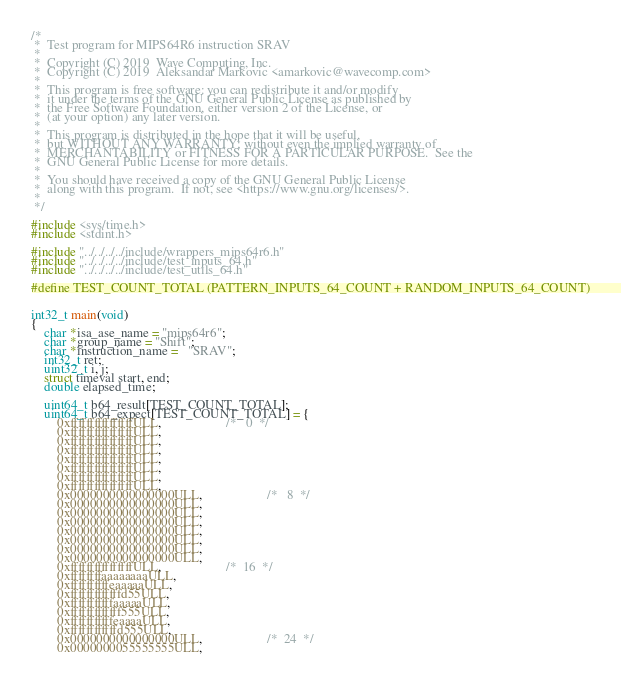Convert code to text. <code><loc_0><loc_0><loc_500><loc_500><_C_>/*
 *  Test program for MIPS64R6 instruction SRAV
 *
 *  Copyright (C) 2019  Wave Computing, Inc.
 *  Copyright (C) 2019  Aleksandar Markovic <amarkovic@wavecomp.com>
 *
 *  This program is free software: you can redistribute it and/or modify
 *  it under the terms of the GNU General Public License as published by
 *  the Free Software Foundation, either version 2 of the License, or
 *  (at your option) any later version.
 *
 *  This program is distributed in the hope that it will be useful,
 *  but WITHOUT ANY WARRANTY; without even the implied warranty of
 *  MERCHANTABILITY or FITNESS FOR A PARTICULAR PURPOSE.  See the
 *  GNU General Public License for more details.
 *
 *  You should have received a copy of the GNU General Public License
 *  along with this program.  If not, see <https://www.gnu.org/licenses/>.
 *
 */

#include <sys/time.h>
#include <stdint.h>

#include "../../../../include/wrappers_mips64r6.h"
#include "../../../../include/test_inputs_64.h"
#include "../../../../include/test_utils_64.h"

#define TEST_COUNT_TOTAL (PATTERN_INPUTS_64_COUNT + RANDOM_INPUTS_64_COUNT)


int32_t main(void)
{
    char *isa_ase_name = "mips64r6";
    char *group_name = "Shift";
    char *instruction_name =   "SRAV";
    int32_t ret;
    uint32_t i, j;
    struct timeval start, end;
    double elapsed_time;

    uint64_t b64_result[TEST_COUNT_TOTAL];
    uint64_t b64_expect[TEST_COUNT_TOTAL] = {
        0xffffffffffffffffULL,                    /*   0  */
        0xffffffffffffffffULL,
        0xffffffffffffffffULL,
        0xffffffffffffffffULL,
        0xffffffffffffffffULL,
        0xffffffffffffffffULL,
        0xffffffffffffffffULL,
        0xffffffffffffffffULL,
        0x0000000000000000ULL,                    /*   8  */
        0x0000000000000000ULL,
        0x0000000000000000ULL,
        0x0000000000000000ULL,
        0x0000000000000000ULL,
        0x0000000000000000ULL,
        0x0000000000000000ULL,
        0x0000000000000000ULL,
        0xffffffffffffffffULL,                    /*  16  */
        0xffffffffaaaaaaaaULL,
        0xffffffffffeaaaaaULL,
        0xfffffffffffffd55ULL,
        0xfffffffffffaaaaaULL,
        0xfffffffffffff555ULL,
        0xfffffffffffeaaaaULL,
        0xffffffffffffd555ULL,
        0x0000000000000000ULL,                    /*  24  */
        0x0000000055555555ULL,</code> 